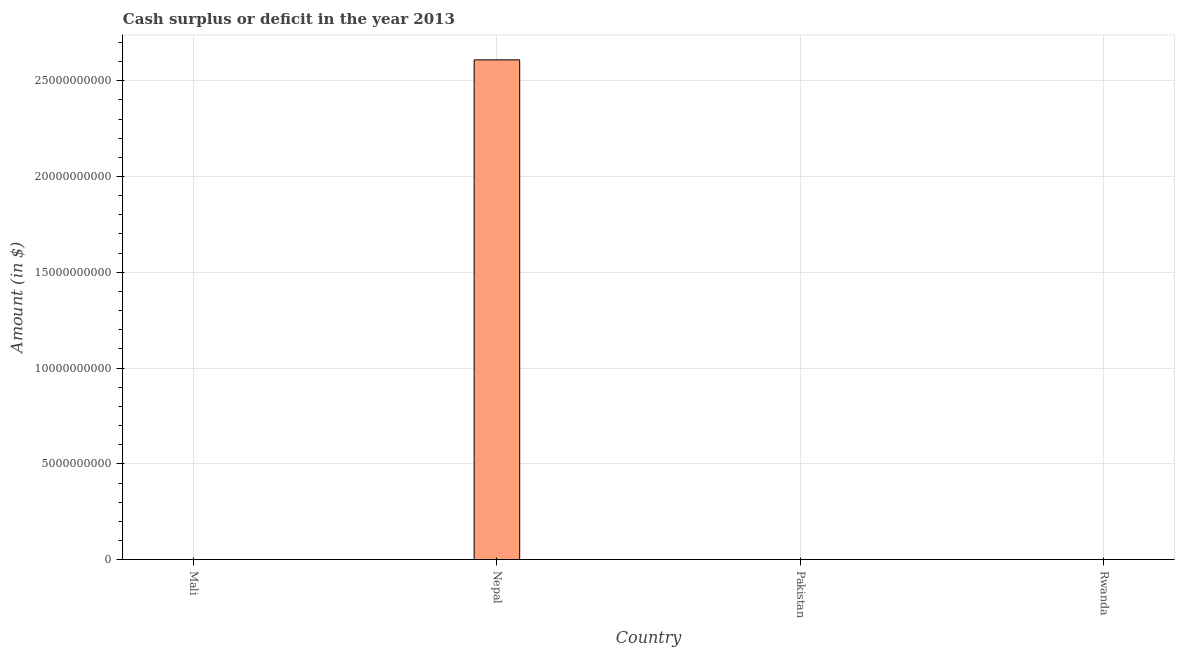Does the graph contain grids?
Your response must be concise. Yes. What is the title of the graph?
Offer a terse response. Cash surplus or deficit in the year 2013. What is the label or title of the X-axis?
Your response must be concise. Country. What is the label or title of the Y-axis?
Provide a short and direct response. Amount (in $). Across all countries, what is the maximum cash surplus or deficit?
Keep it short and to the point. 2.61e+1. Across all countries, what is the minimum cash surplus or deficit?
Your answer should be very brief. 0. In which country was the cash surplus or deficit maximum?
Keep it short and to the point. Nepal. What is the sum of the cash surplus or deficit?
Your response must be concise. 2.61e+1. What is the average cash surplus or deficit per country?
Your response must be concise. 6.52e+09. What is the difference between the highest and the lowest cash surplus or deficit?
Your answer should be very brief. 2.61e+1. How many bars are there?
Offer a terse response. 1. How many countries are there in the graph?
Your answer should be very brief. 4. Are the values on the major ticks of Y-axis written in scientific E-notation?
Ensure brevity in your answer.  No. What is the Amount (in $) of Mali?
Provide a succinct answer. 0. What is the Amount (in $) in Nepal?
Your answer should be very brief. 2.61e+1. 